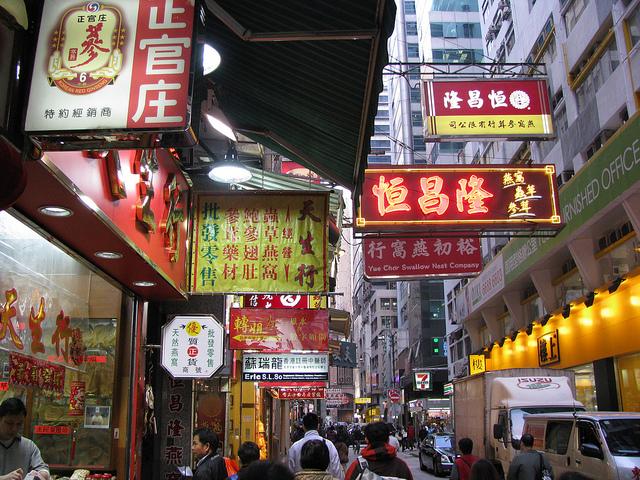Is this a shopping mall?
Be succinct. No. Is this a busy street?
Keep it brief. Yes. What language are the signs written in?
Keep it brief. Chinese. 